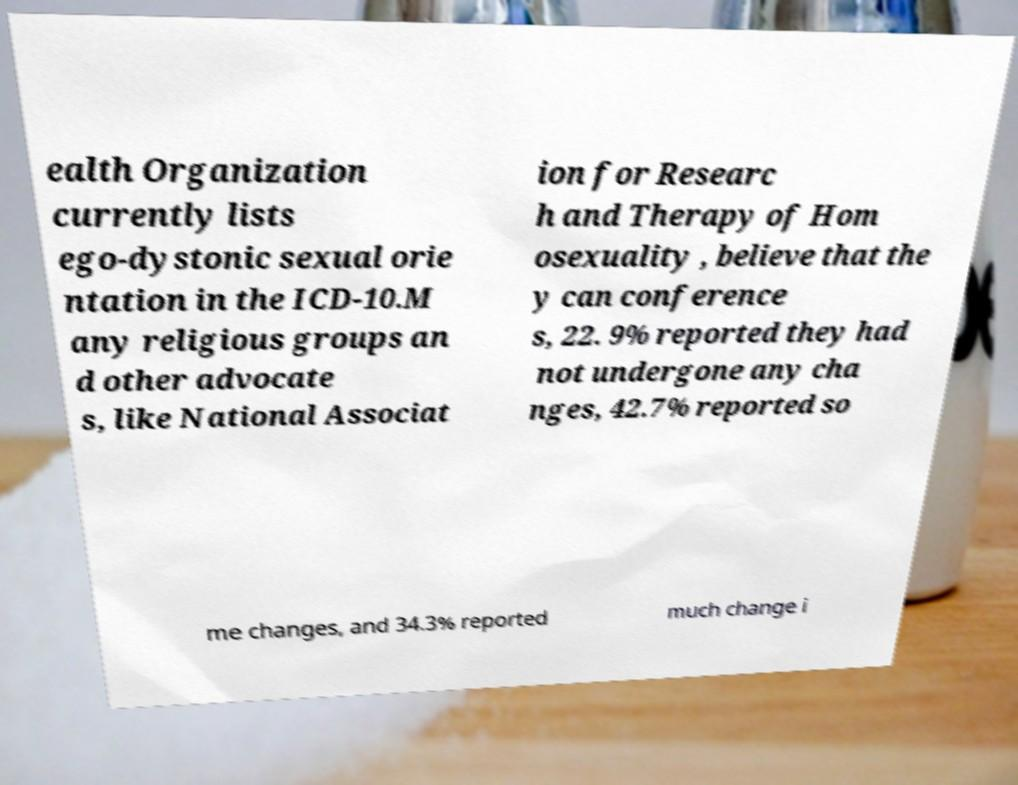Can you accurately transcribe the text from the provided image for me? ealth Organization currently lists ego-dystonic sexual orie ntation in the ICD-10.M any religious groups an d other advocate s, like National Associat ion for Researc h and Therapy of Hom osexuality , believe that the y can conference s, 22. 9% reported they had not undergone any cha nges, 42.7% reported so me changes, and 34.3% reported much change i 